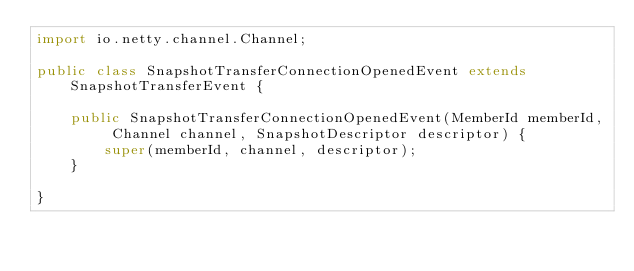<code> <loc_0><loc_0><loc_500><loc_500><_Java_>import io.netty.channel.Channel;

public class SnapshotTransferConnectionOpenedEvent extends SnapshotTransferEvent {

    public SnapshotTransferConnectionOpenedEvent(MemberId memberId, Channel channel, SnapshotDescriptor descriptor) {
        super(memberId, channel, descriptor);
    }

}
</code> 